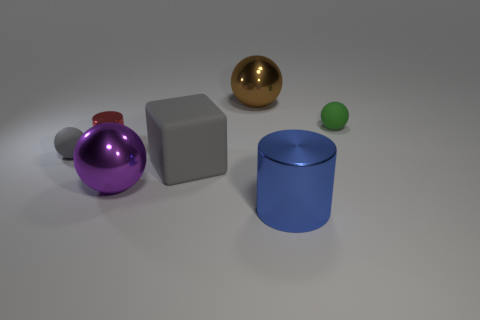Add 1 brown metal balls. How many objects exist? 8 Subtract all spheres. How many objects are left? 3 Subtract 0 cyan cubes. How many objects are left? 7 Subtract all tiny brown metallic blocks. Subtract all green objects. How many objects are left? 6 Add 4 purple shiny spheres. How many purple shiny spheres are left? 5 Add 2 green matte spheres. How many green matte spheres exist? 3 